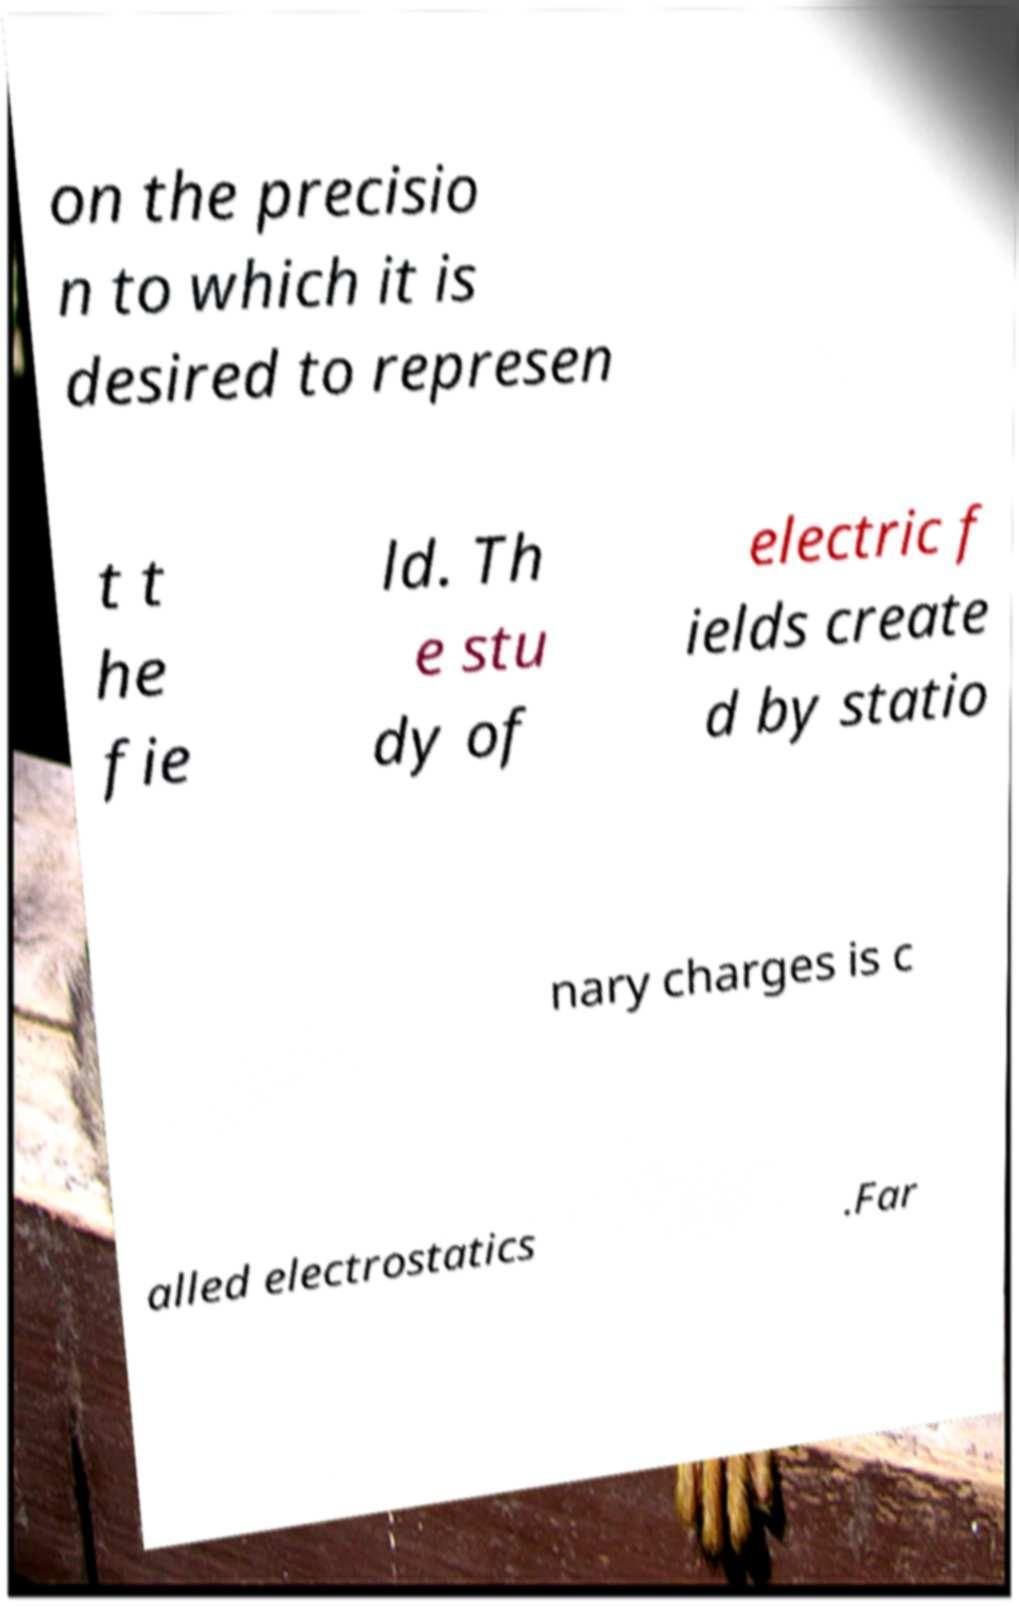Could you extract and type out the text from this image? on the precisio n to which it is desired to represen t t he fie ld. Th e stu dy of electric f ields create d by statio nary charges is c alled electrostatics .Far 